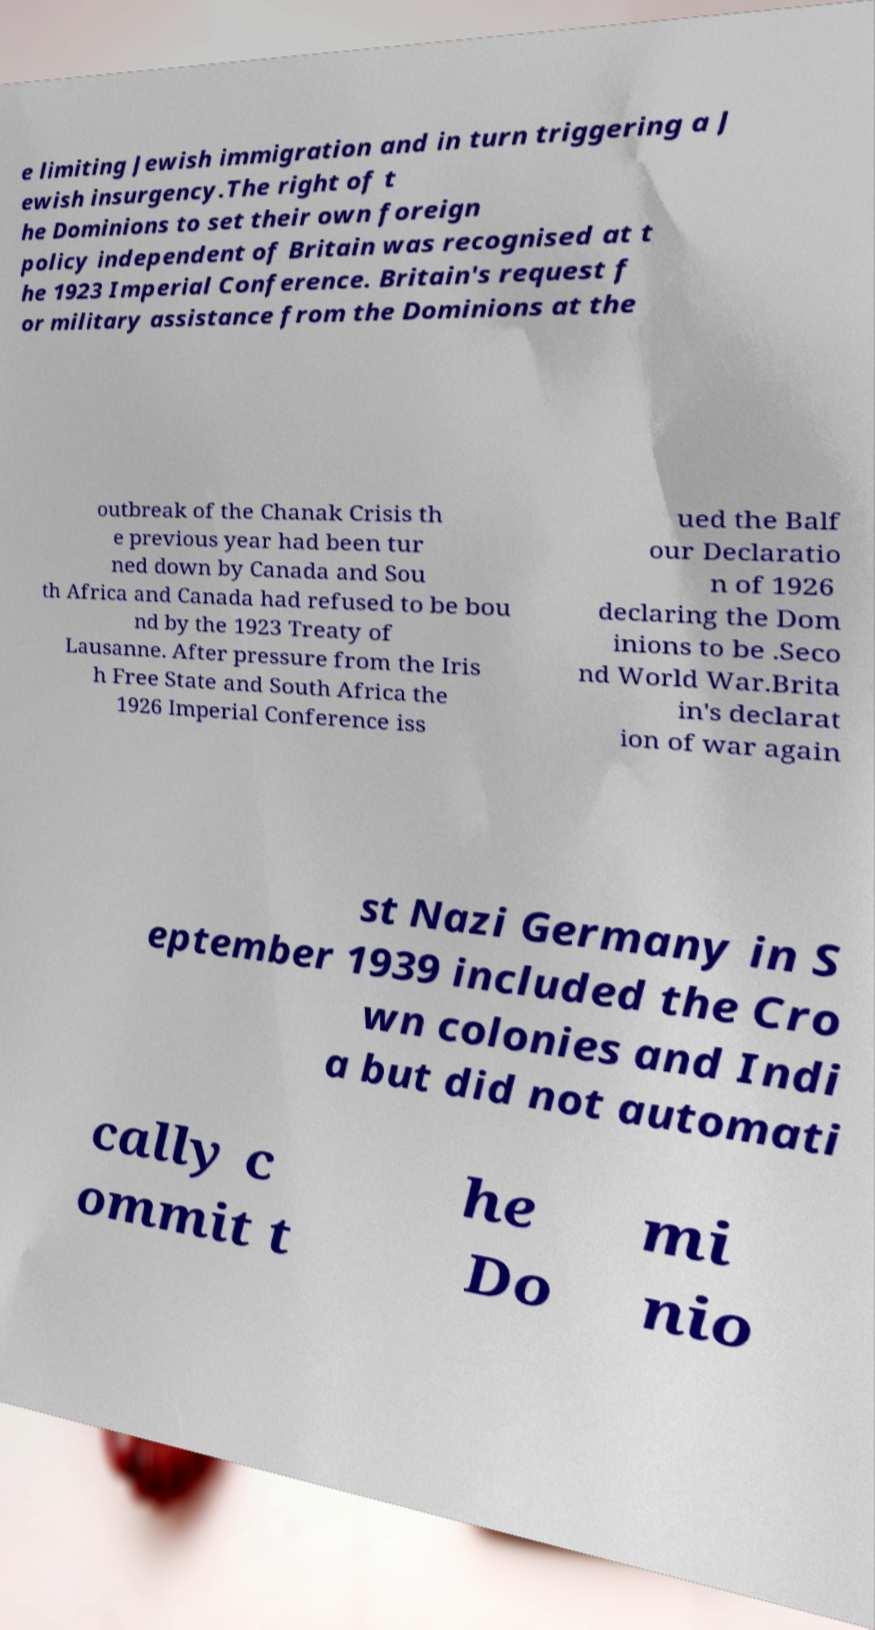For documentation purposes, I need the text within this image transcribed. Could you provide that? e limiting Jewish immigration and in turn triggering a J ewish insurgency.The right of t he Dominions to set their own foreign policy independent of Britain was recognised at t he 1923 Imperial Conference. Britain's request f or military assistance from the Dominions at the outbreak of the Chanak Crisis th e previous year had been tur ned down by Canada and Sou th Africa and Canada had refused to be bou nd by the 1923 Treaty of Lausanne. After pressure from the Iris h Free State and South Africa the 1926 Imperial Conference iss ued the Balf our Declaratio n of 1926 declaring the Dom inions to be .Seco nd World War.Brita in's declarat ion of war again st Nazi Germany in S eptember 1939 included the Cro wn colonies and Indi a but did not automati cally c ommit t he Do mi nio 